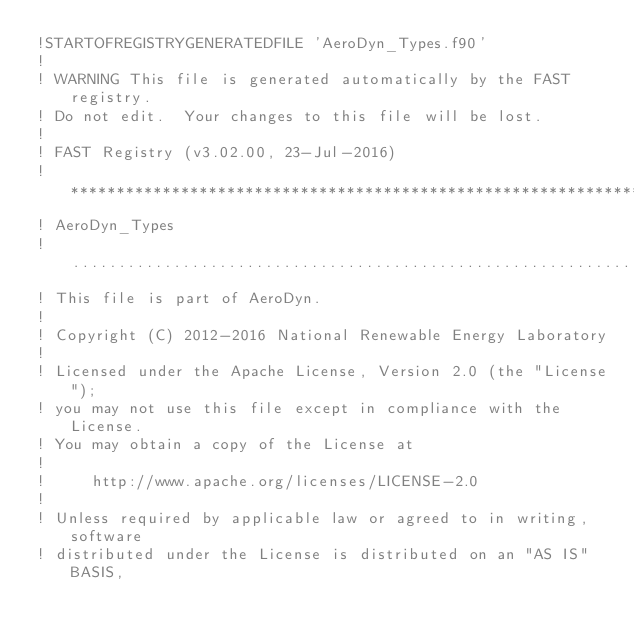Convert code to text. <code><loc_0><loc_0><loc_500><loc_500><_FORTRAN_>!STARTOFREGISTRYGENERATEDFILE 'AeroDyn_Types.f90'
!
! WARNING This file is generated automatically by the FAST registry.
! Do not edit.  Your changes to this file will be lost.
!
! FAST Registry (v3.02.00, 23-Jul-2016)
!*********************************************************************************************************************************
! AeroDyn_Types
!.................................................................................................................................
! This file is part of AeroDyn.
!
! Copyright (C) 2012-2016 National Renewable Energy Laboratory
!
! Licensed under the Apache License, Version 2.0 (the "License");
! you may not use this file except in compliance with the License.
! You may obtain a copy of the License at
!
!     http://www.apache.org/licenses/LICENSE-2.0
!
! Unless required by applicable law or agreed to in writing, software
! distributed under the License is distributed on an "AS IS" BASIS,</code> 